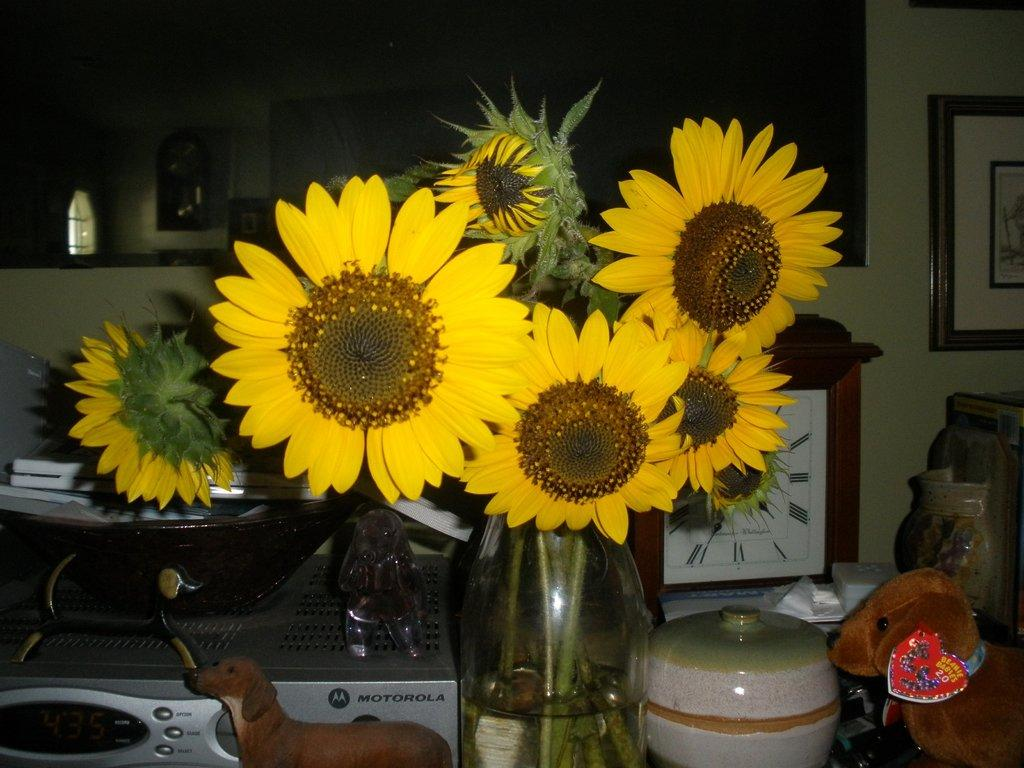What can be seen in the background of the image? There is a window and a frame over a wall in the background of the image. What objects are on the table in the image? There is a flower vase, dolls, a device, a clock, and a pot on the table in the image. How many minutes does the bird take to fly across the room in the image? There is no bird present in the image, so it is not possible to determine how many minutes it would take for a bird to fly across the room. What force is being exerted on the pot by the device in the image? There is no information about the device's function or purpose in the image, so it is not possible to determine the force being exerted on the pot. 